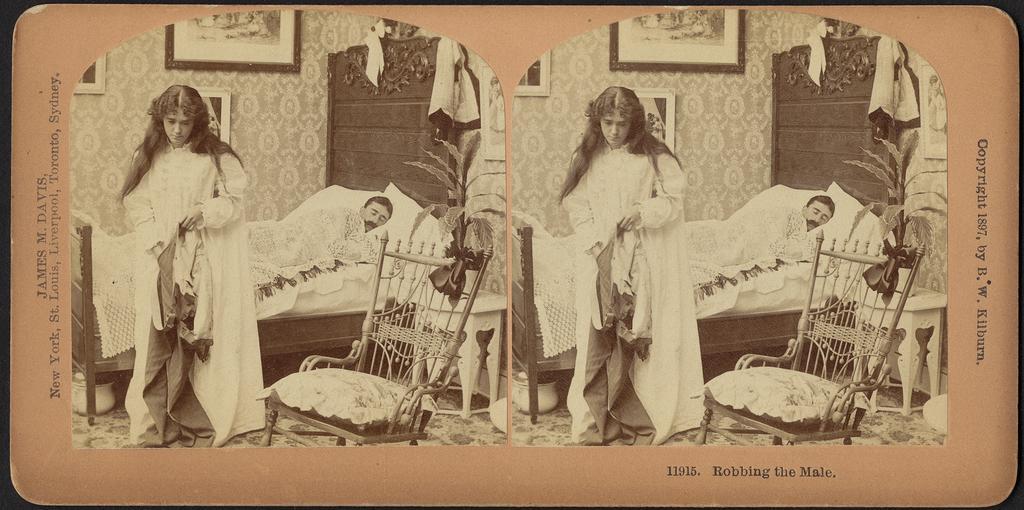How would you summarize this image in a sentence or two? In this image we can see one photo with two collage pictures and some text on the photo. In this photo we can see two objects under the beds, two chairs, two men sleeping on the beds, some objects on the beds, some photo frames attached to the walls, two carpets on the floor, two pots with plants on the tables, two objects on the floor on the bottom right side of the image, two bed sheets, some pillows on the beds, two women standing and holding one object. 